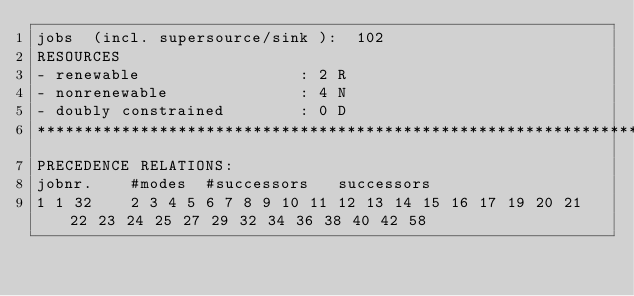Convert code to text. <code><loc_0><loc_0><loc_500><loc_500><_ObjectiveC_>jobs  (incl. supersource/sink ):	102
RESOURCES
- renewable                 : 2 R
- nonrenewable              : 4 N
- doubly constrained        : 0 D
************************************************************************
PRECEDENCE RELATIONS:
jobnr.    #modes  #successors   successors
1	1	32		2 3 4 5 6 7 8 9 10 11 12 13 14 15 16 17 19 20 21 22 23 24 25 27 29 32 34 36 38 40 42 58 </code> 